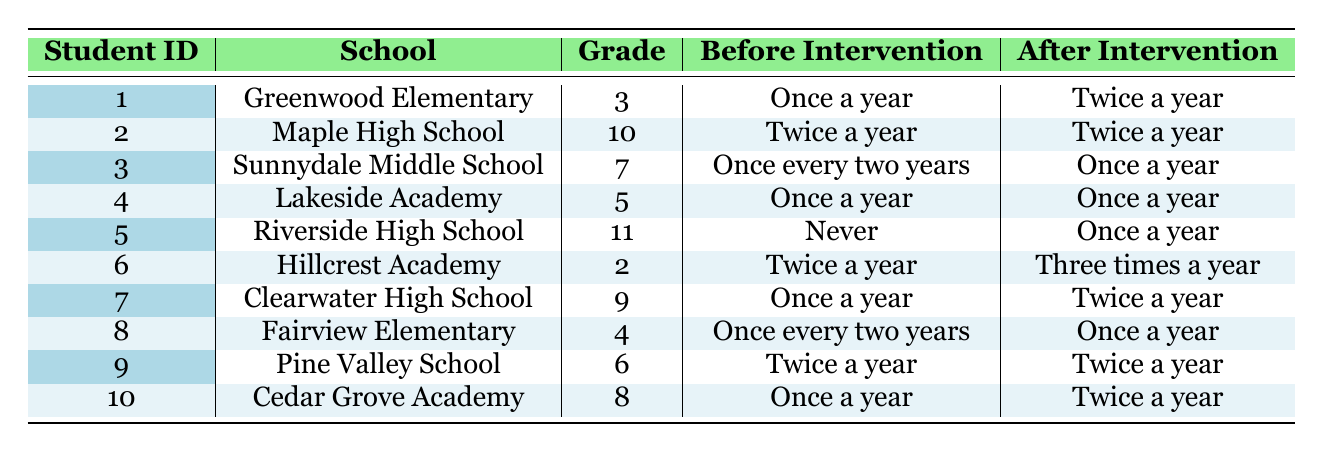What was the check-up frequency for student ID 5 before the intervention? Referring to the table, student ID 5 had a check-up frequency of "Never" before the intervention.
Answer: Never How many students increased their check-up frequency after the intervention? By analyzing the table, the following students increased their check-up frequency: Student ID 1 (once a year to twice a year), Student ID 3 (once every two years to once a year), Student ID 5 (never to once a year), Student ID 6 (twice a year to three times a year), Student ID 7 (once a year to twice a year), Student ID 8 (once every two years to once a year), and Student ID 10 (once a year to twice a year). This totals 7 students.
Answer: 7 Is it true that any student maintained the same frequency of dental check-ups before and after the intervention? Looking at the table, student ID 2 (twice a year to twice a year) and student ID 4 (once a year to once a year) did not change their check-up frequency, indicating the statement is true.
Answer: Yes What is the difference in check-up frequency for student ID 6 before and after the intervention? Student ID 6 had a frequency of "Twice a year" before the intervention and increased to "Three times a year" after the intervention, thus the difference in frequency is one additional check-up per year.
Answer: One time On average, how many times did the students check-up after the intervention? After the intervention, the frequencies are: twice a year (student ID 1), twice a year (student ID 2), once a year (student ID 3), once a year (student ID 4), once a year (student ID 5), three times a year (student ID 6), twice a year (student ID 7), once a year (student ID 8), twice a year (student ID 9), and twice a year (student ID 10). This gives: 2, 2, 1, 1, 1, 3, 2, 1, 2, 2. The sum is 18 and the average is 18/10 = 1.8 times per year.
Answer: 1.8 times per year 